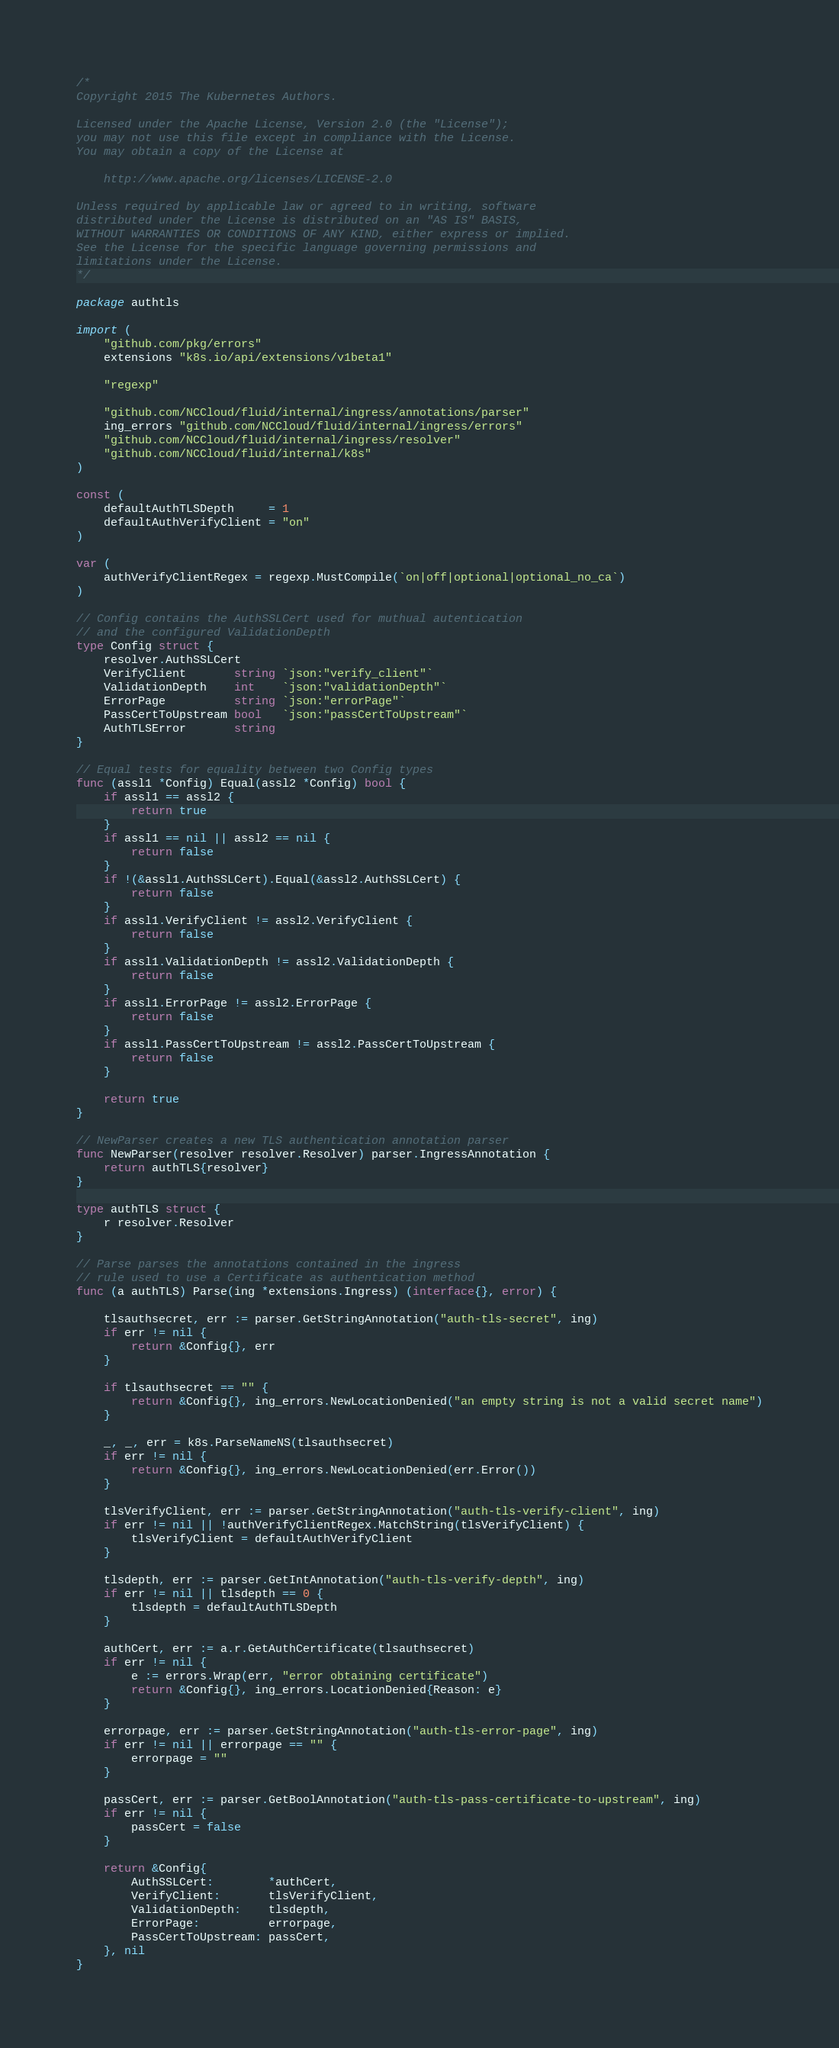<code> <loc_0><loc_0><loc_500><loc_500><_Go_>/*
Copyright 2015 The Kubernetes Authors.

Licensed under the Apache License, Version 2.0 (the "License");
you may not use this file except in compliance with the License.
You may obtain a copy of the License at

    http://www.apache.org/licenses/LICENSE-2.0

Unless required by applicable law or agreed to in writing, software
distributed under the License is distributed on an "AS IS" BASIS,
WITHOUT WARRANTIES OR CONDITIONS OF ANY KIND, either express or implied.
See the License for the specific language governing permissions and
limitations under the License.
*/

package authtls

import (
	"github.com/pkg/errors"
	extensions "k8s.io/api/extensions/v1beta1"

	"regexp"

	"github.com/NCCloud/fluid/internal/ingress/annotations/parser"
	ing_errors "github.com/NCCloud/fluid/internal/ingress/errors"
	"github.com/NCCloud/fluid/internal/ingress/resolver"
	"github.com/NCCloud/fluid/internal/k8s"
)

const (
	defaultAuthTLSDepth     = 1
	defaultAuthVerifyClient = "on"
)

var (
	authVerifyClientRegex = regexp.MustCompile(`on|off|optional|optional_no_ca`)
)

// Config contains the AuthSSLCert used for muthual autentication
// and the configured ValidationDepth
type Config struct {
	resolver.AuthSSLCert
	VerifyClient       string `json:"verify_client"`
	ValidationDepth    int    `json:"validationDepth"`
	ErrorPage          string `json:"errorPage"`
	PassCertToUpstream bool   `json:"passCertToUpstream"`
	AuthTLSError       string
}

// Equal tests for equality between two Config types
func (assl1 *Config) Equal(assl2 *Config) bool {
	if assl1 == assl2 {
		return true
	}
	if assl1 == nil || assl2 == nil {
		return false
	}
	if !(&assl1.AuthSSLCert).Equal(&assl2.AuthSSLCert) {
		return false
	}
	if assl1.VerifyClient != assl2.VerifyClient {
		return false
	}
	if assl1.ValidationDepth != assl2.ValidationDepth {
		return false
	}
	if assl1.ErrorPage != assl2.ErrorPage {
		return false
	}
	if assl1.PassCertToUpstream != assl2.PassCertToUpstream {
		return false
	}

	return true
}

// NewParser creates a new TLS authentication annotation parser
func NewParser(resolver resolver.Resolver) parser.IngressAnnotation {
	return authTLS{resolver}
}

type authTLS struct {
	r resolver.Resolver
}

// Parse parses the annotations contained in the ingress
// rule used to use a Certificate as authentication method
func (a authTLS) Parse(ing *extensions.Ingress) (interface{}, error) {

	tlsauthsecret, err := parser.GetStringAnnotation("auth-tls-secret", ing)
	if err != nil {
		return &Config{}, err
	}

	if tlsauthsecret == "" {
		return &Config{}, ing_errors.NewLocationDenied("an empty string is not a valid secret name")
	}

	_, _, err = k8s.ParseNameNS(tlsauthsecret)
	if err != nil {
		return &Config{}, ing_errors.NewLocationDenied(err.Error())
	}

	tlsVerifyClient, err := parser.GetStringAnnotation("auth-tls-verify-client", ing)
	if err != nil || !authVerifyClientRegex.MatchString(tlsVerifyClient) {
		tlsVerifyClient = defaultAuthVerifyClient
	}

	tlsdepth, err := parser.GetIntAnnotation("auth-tls-verify-depth", ing)
	if err != nil || tlsdepth == 0 {
		tlsdepth = defaultAuthTLSDepth
	}

	authCert, err := a.r.GetAuthCertificate(tlsauthsecret)
	if err != nil {
		e := errors.Wrap(err, "error obtaining certificate")
		return &Config{}, ing_errors.LocationDenied{Reason: e}
	}

	errorpage, err := parser.GetStringAnnotation("auth-tls-error-page", ing)
	if err != nil || errorpage == "" {
		errorpage = ""
	}

	passCert, err := parser.GetBoolAnnotation("auth-tls-pass-certificate-to-upstream", ing)
	if err != nil {
		passCert = false
	}

	return &Config{
		AuthSSLCert:        *authCert,
		VerifyClient:       tlsVerifyClient,
		ValidationDepth:    tlsdepth,
		ErrorPage:          errorpage,
		PassCertToUpstream: passCert,
	}, nil
}
</code> 